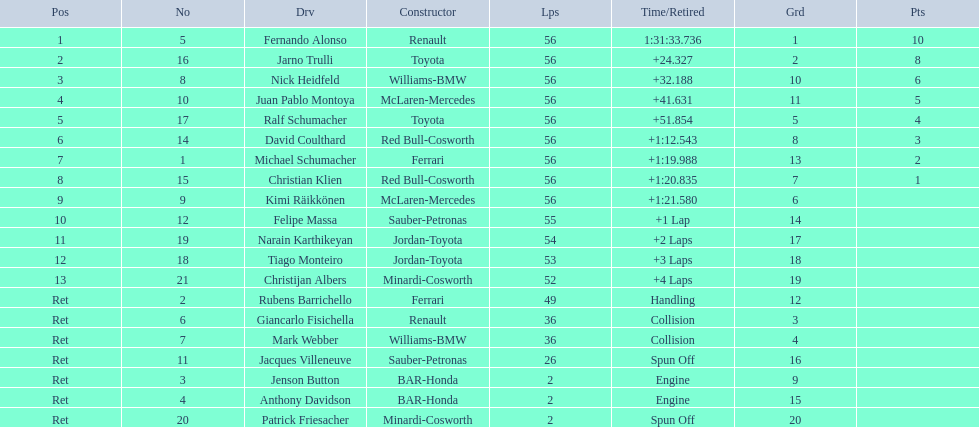Who raced during the 2005 malaysian grand prix? Fernando Alonso, Jarno Trulli, Nick Heidfeld, Juan Pablo Montoya, Ralf Schumacher, David Coulthard, Michael Schumacher, Christian Klien, Kimi Räikkönen, Felipe Massa, Narain Karthikeyan, Tiago Monteiro, Christijan Albers, Rubens Barrichello, Giancarlo Fisichella, Mark Webber, Jacques Villeneuve, Jenson Button, Anthony Davidson, Patrick Friesacher. What were their finishing times? 1:31:33.736, +24.327, +32.188, +41.631, +51.854, +1:12.543, +1:19.988, +1:20.835, +1:21.580, +1 Lap, +2 Laps, +3 Laps, +4 Laps, Handling, Collision, Collision, Spun Off, Engine, Engine, Spun Off. What was fernando alonso's finishing time? 1:31:33.736. 